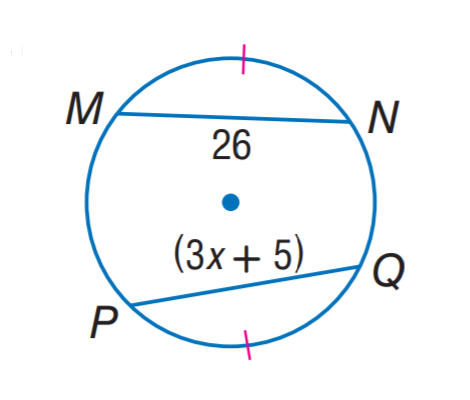Question: Find x.
Choices:
A. 5
B. 7
C. 8
D. 26
Answer with the letter. Answer: B 